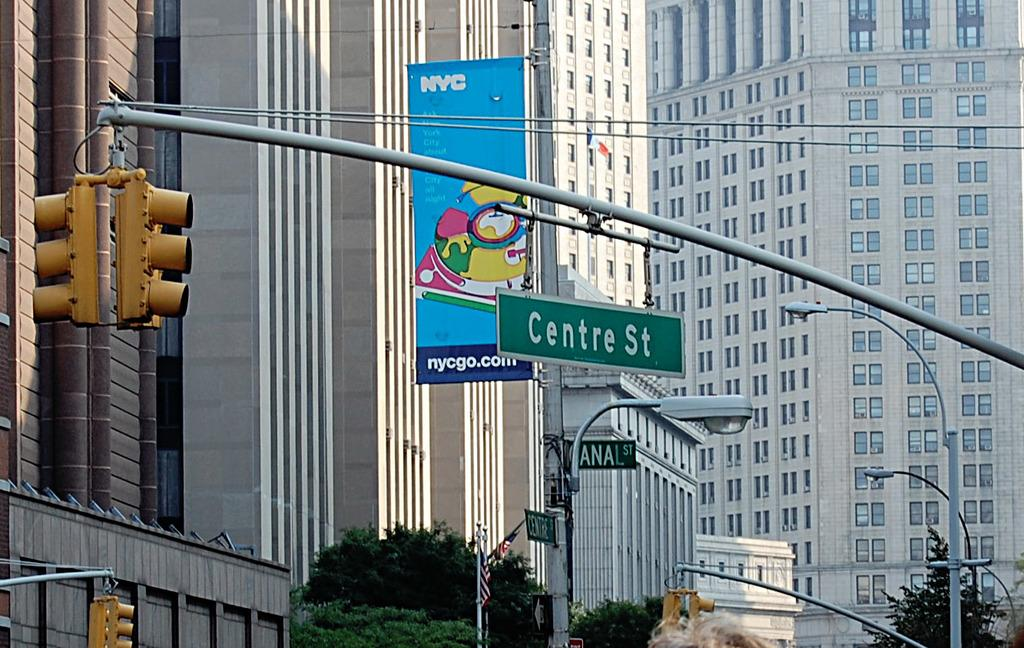What is the main subject in the center of the image? There are buildings in the center of the image. What can be seen in the foreground of the image? Boards, traffic signals, poles, and trees are present in the foreground of the image. Can you describe the traffic signals in the image? Traffic signals are present in the foreground of the image. What type of vegetation is visible in the foreground of the image? Trees are present in the foreground of the image. What type of bone can be seen in the image? There is no bone present in the image. Can you describe the flight of the chicken in the image? There is no chicken present in the image. 